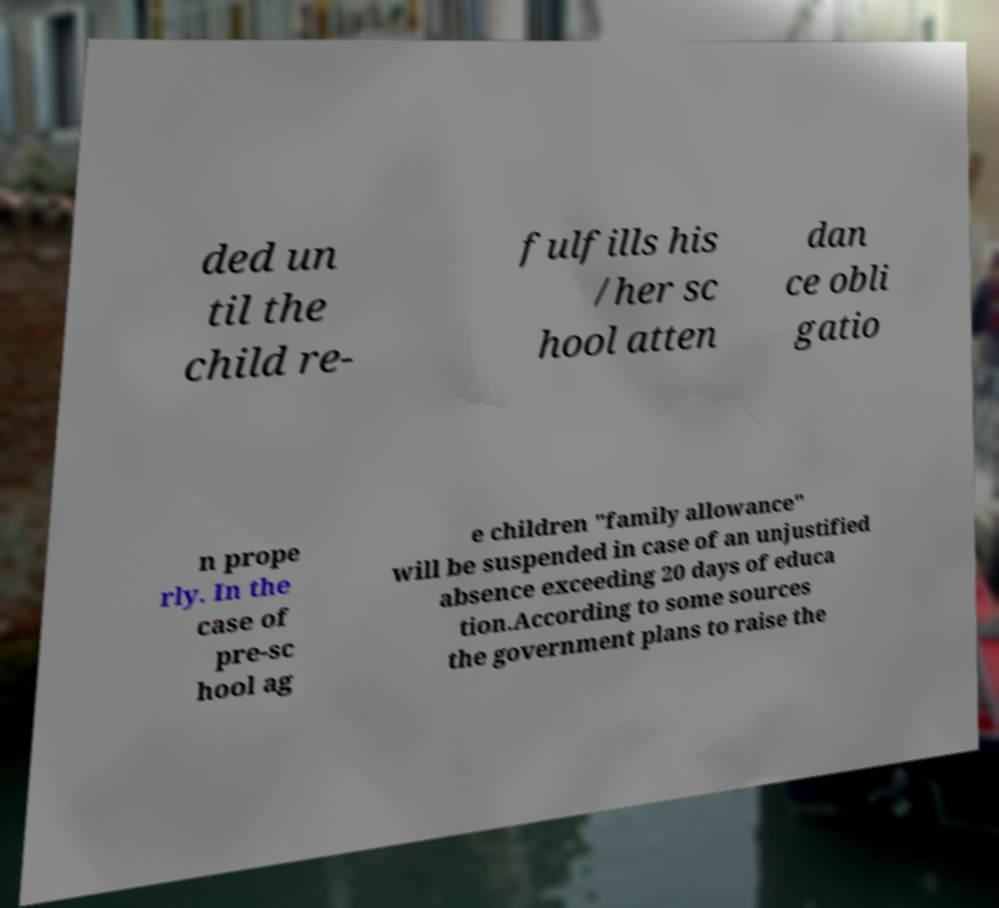I need the written content from this picture converted into text. Can you do that? ded un til the child re- fulfills his /her sc hool atten dan ce obli gatio n prope rly. In the case of pre-sc hool ag e children "family allowance" will be suspended in case of an unjustified absence exceeding 20 days of educa tion.According to some sources the government plans to raise the 